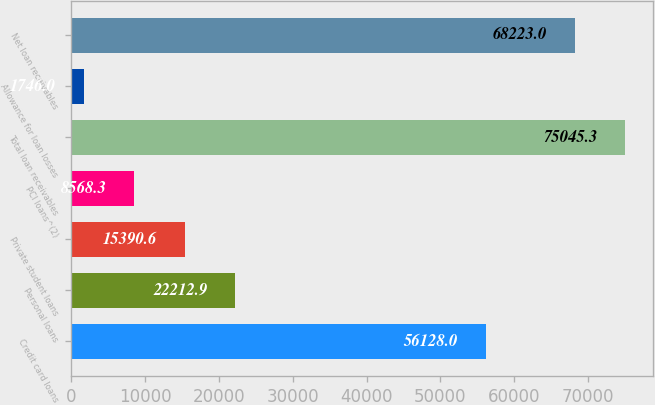Convert chart to OTSL. <chart><loc_0><loc_0><loc_500><loc_500><bar_chart><fcel>Credit card loans<fcel>Personal loans<fcel>Private student loans<fcel>PCI loans^(2)<fcel>Total loan receivables<fcel>Allowance for loan losses<fcel>Net loan receivables<nl><fcel>56128<fcel>22212.9<fcel>15390.6<fcel>8568.3<fcel>75045.3<fcel>1746<fcel>68223<nl></chart> 